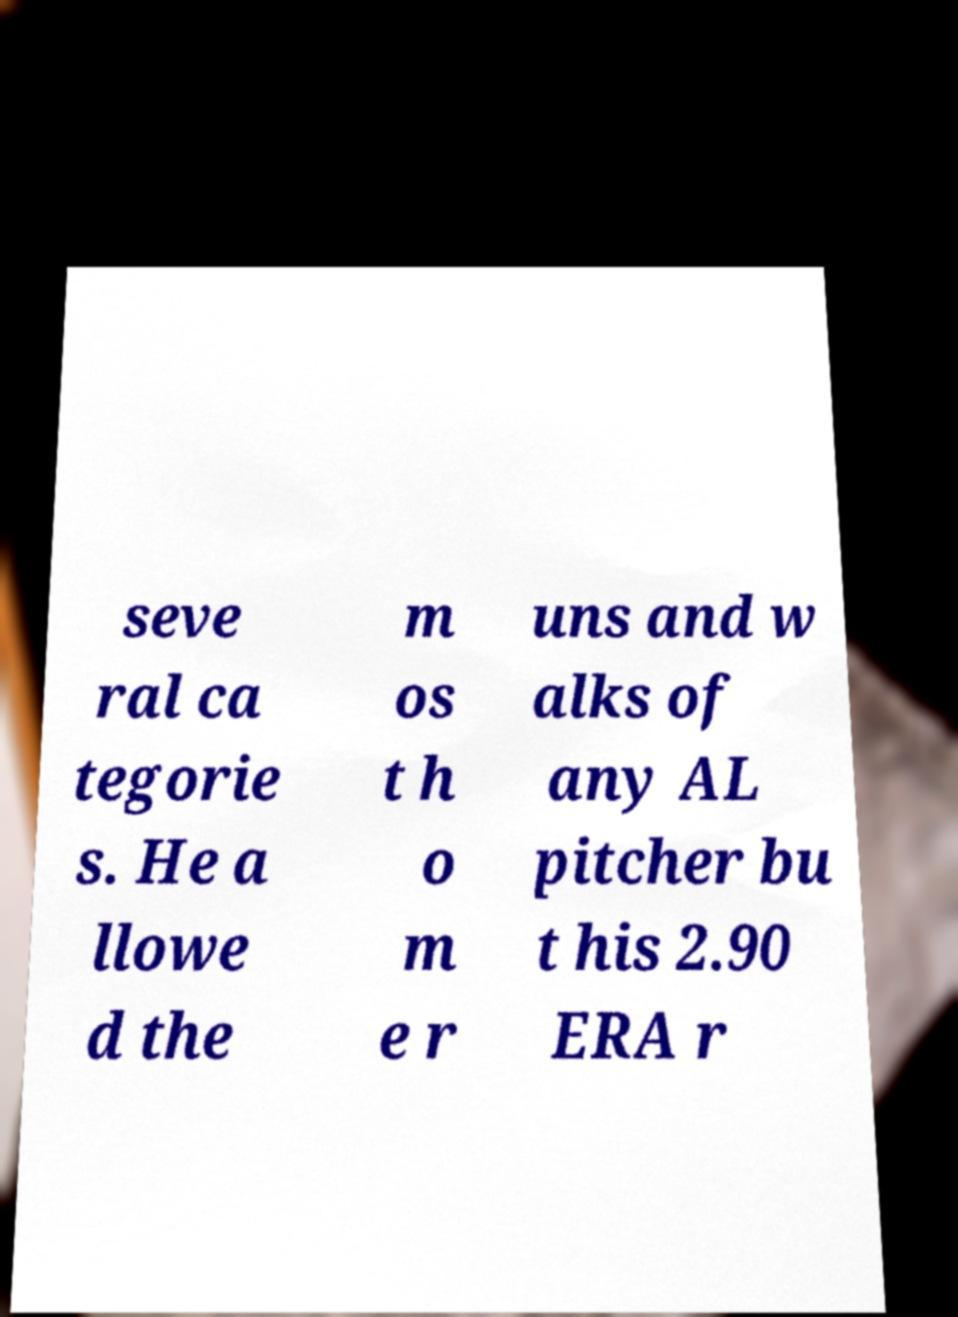For documentation purposes, I need the text within this image transcribed. Could you provide that? seve ral ca tegorie s. He a llowe d the m os t h o m e r uns and w alks of any AL pitcher bu t his 2.90 ERA r 